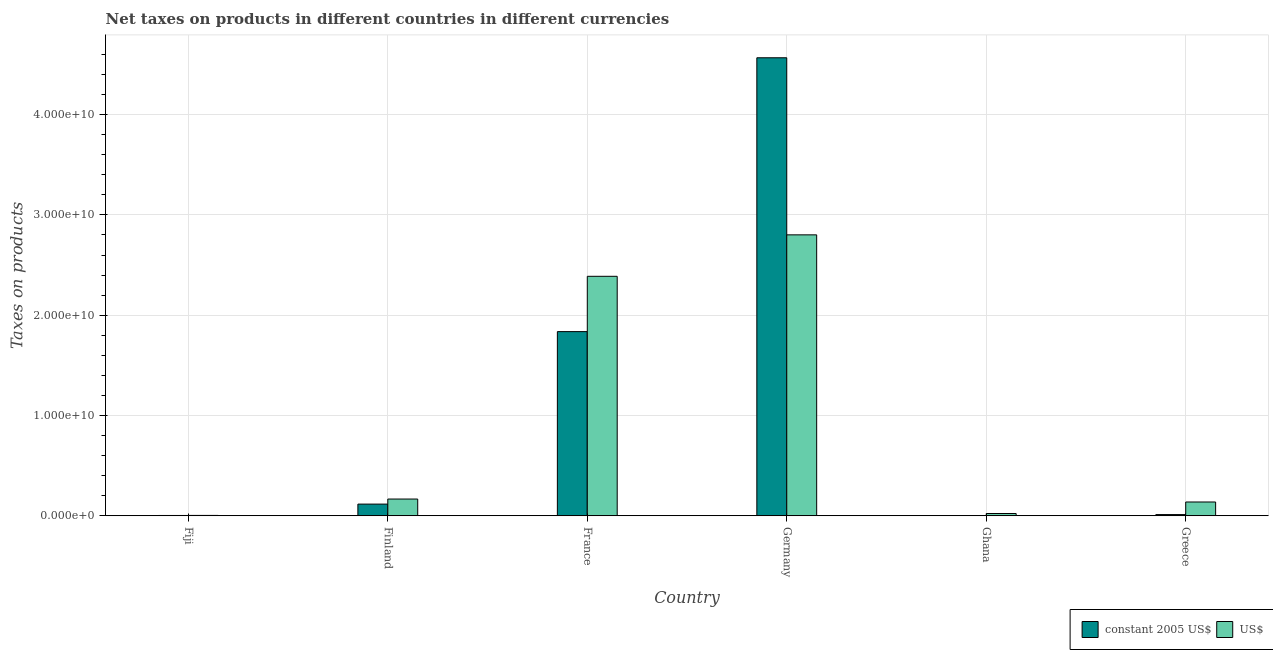Are the number of bars on each tick of the X-axis equal?
Offer a terse response. Yes. How many bars are there on the 4th tick from the right?
Provide a succinct answer. 2. What is the label of the 1st group of bars from the left?
Provide a succinct answer. Fiji. What is the net taxes in constant 2005 us$ in Fiji?
Your response must be concise. 3.08e+07. Across all countries, what is the maximum net taxes in us$?
Ensure brevity in your answer.  2.80e+1. Across all countries, what is the minimum net taxes in constant 2005 us$?
Offer a terse response. 3.03e+04. In which country was the net taxes in constant 2005 us$ maximum?
Provide a short and direct response. Germany. In which country was the net taxes in constant 2005 us$ minimum?
Provide a succinct answer. Ghana. What is the total net taxes in us$ in the graph?
Provide a short and direct response. 5.52e+1. What is the difference between the net taxes in constant 2005 us$ in Ghana and that in Greece?
Make the answer very short. -1.21e+08. What is the difference between the net taxes in us$ in Greece and the net taxes in constant 2005 us$ in Finland?
Your answer should be very brief. 2.11e+08. What is the average net taxes in constant 2005 us$ per country?
Your response must be concise. 1.09e+1. What is the difference between the net taxes in constant 2005 us$ and net taxes in us$ in Fiji?
Keep it short and to the point. -6.52e+06. In how many countries, is the net taxes in constant 2005 us$ greater than 10000000000 units?
Your answer should be very brief. 2. What is the ratio of the net taxes in constant 2005 us$ in France to that in Germany?
Offer a very short reply. 0.4. Is the difference between the net taxes in us$ in Fiji and Ghana greater than the difference between the net taxes in constant 2005 us$ in Fiji and Ghana?
Offer a very short reply. No. What is the difference between the highest and the second highest net taxes in constant 2005 us$?
Your response must be concise. 2.73e+1. What is the difference between the highest and the lowest net taxes in us$?
Provide a short and direct response. 2.80e+1. In how many countries, is the net taxes in constant 2005 us$ greater than the average net taxes in constant 2005 us$ taken over all countries?
Provide a succinct answer. 2. What does the 2nd bar from the left in France represents?
Your response must be concise. US$. What does the 2nd bar from the right in Fiji represents?
Give a very brief answer. Constant 2005 us$. How many bars are there?
Ensure brevity in your answer.  12. Are all the bars in the graph horizontal?
Your answer should be very brief. No. How many countries are there in the graph?
Your answer should be compact. 6. Are the values on the major ticks of Y-axis written in scientific E-notation?
Provide a succinct answer. Yes. Does the graph contain any zero values?
Keep it short and to the point. No. Does the graph contain grids?
Your answer should be compact. Yes. Where does the legend appear in the graph?
Make the answer very short. Bottom right. What is the title of the graph?
Ensure brevity in your answer.  Net taxes on products in different countries in different currencies. Does "Agricultural land" appear as one of the legend labels in the graph?
Give a very brief answer. No. What is the label or title of the X-axis?
Ensure brevity in your answer.  Country. What is the label or title of the Y-axis?
Your answer should be compact. Taxes on products. What is the Taxes on products of constant 2005 US$ in Fiji?
Keep it short and to the point. 3.08e+07. What is the Taxes on products of US$ in Fiji?
Keep it short and to the point. 3.73e+07. What is the Taxes on products in constant 2005 US$ in Finland?
Keep it short and to the point. 1.17e+09. What is the Taxes on products in US$ in Finland?
Make the answer very short. 1.67e+09. What is the Taxes on products of constant 2005 US$ in France?
Your answer should be compact. 1.84e+1. What is the Taxes on products of US$ in France?
Provide a succinct answer. 2.39e+1. What is the Taxes on products of constant 2005 US$ in Germany?
Make the answer very short. 4.57e+1. What is the Taxes on products in US$ in Germany?
Your response must be concise. 2.80e+1. What is the Taxes on products of constant 2005 US$ in Ghana?
Ensure brevity in your answer.  3.03e+04. What is the Taxes on products of US$ in Ghana?
Provide a succinct answer. 2.27e+08. What is the Taxes on products of constant 2005 US$ in Greece?
Your answer should be compact. 1.21e+08. What is the Taxes on products in US$ in Greece?
Offer a terse response. 1.38e+09. Across all countries, what is the maximum Taxes on products of constant 2005 US$?
Your answer should be very brief. 4.57e+1. Across all countries, what is the maximum Taxes on products of US$?
Your answer should be compact. 2.80e+1. Across all countries, what is the minimum Taxes on products in constant 2005 US$?
Your answer should be compact. 3.03e+04. Across all countries, what is the minimum Taxes on products of US$?
Ensure brevity in your answer.  3.73e+07. What is the total Taxes on products in constant 2005 US$ in the graph?
Your answer should be compact. 6.53e+1. What is the total Taxes on products in US$ in the graph?
Offer a terse response. 5.52e+1. What is the difference between the Taxes on products in constant 2005 US$ in Fiji and that in Finland?
Make the answer very short. -1.13e+09. What is the difference between the Taxes on products in US$ in Fiji and that in Finland?
Your answer should be very brief. -1.63e+09. What is the difference between the Taxes on products in constant 2005 US$ in Fiji and that in France?
Offer a terse response. -1.83e+1. What is the difference between the Taxes on products in US$ in Fiji and that in France?
Make the answer very short. -2.38e+1. What is the difference between the Taxes on products of constant 2005 US$ in Fiji and that in Germany?
Give a very brief answer. -4.56e+1. What is the difference between the Taxes on products of US$ in Fiji and that in Germany?
Keep it short and to the point. -2.80e+1. What is the difference between the Taxes on products of constant 2005 US$ in Fiji and that in Ghana?
Your response must be concise. 3.08e+07. What is the difference between the Taxes on products of US$ in Fiji and that in Ghana?
Your answer should be compact. -1.90e+08. What is the difference between the Taxes on products of constant 2005 US$ in Fiji and that in Greece?
Keep it short and to the point. -9.03e+07. What is the difference between the Taxes on products of US$ in Fiji and that in Greece?
Provide a short and direct response. -1.34e+09. What is the difference between the Taxes on products in constant 2005 US$ in Finland and that in France?
Keep it short and to the point. -1.72e+1. What is the difference between the Taxes on products in US$ in Finland and that in France?
Ensure brevity in your answer.  -2.22e+1. What is the difference between the Taxes on products in constant 2005 US$ in Finland and that in Germany?
Ensure brevity in your answer.  -4.45e+1. What is the difference between the Taxes on products in US$ in Finland and that in Germany?
Offer a very short reply. -2.63e+1. What is the difference between the Taxes on products in constant 2005 US$ in Finland and that in Ghana?
Your response must be concise. 1.17e+09. What is the difference between the Taxes on products of US$ in Finland and that in Ghana?
Offer a very short reply. 1.44e+09. What is the difference between the Taxes on products of constant 2005 US$ in Finland and that in Greece?
Ensure brevity in your answer.  1.04e+09. What is the difference between the Taxes on products of US$ in Finland and that in Greece?
Provide a succinct answer. 2.95e+08. What is the difference between the Taxes on products in constant 2005 US$ in France and that in Germany?
Give a very brief answer. -2.73e+1. What is the difference between the Taxes on products in US$ in France and that in Germany?
Make the answer very short. -4.13e+09. What is the difference between the Taxes on products in constant 2005 US$ in France and that in Ghana?
Provide a short and direct response. 1.84e+1. What is the difference between the Taxes on products in US$ in France and that in Ghana?
Offer a very short reply. 2.36e+1. What is the difference between the Taxes on products in constant 2005 US$ in France and that in Greece?
Ensure brevity in your answer.  1.82e+1. What is the difference between the Taxes on products of US$ in France and that in Greece?
Make the answer very short. 2.25e+1. What is the difference between the Taxes on products in constant 2005 US$ in Germany and that in Ghana?
Provide a succinct answer. 4.57e+1. What is the difference between the Taxes on products of US$ in Germany and that in Ghana?
Make the answer very short. 2.78e+1. What is the difference between the Taxes on products in constant 2005 US$ in Germany and that in Greece?
Ensure brevity in your answer.  4.55e+1. What is the difference between the Taxes on products in US$ in Germany and that in Greece?
Provide a succinct answer. 2.66e+1. What is the difference between the Taxes on products in constant 2005 US$ in Ghana and that in Greece?
Provide a short and direct response. -1.21e+08. What is the difference between the Taxes on products in US$ in Ghana and that in Greece?
Your response must be concise. -1.15e+09. What is the difference between the Taxes on products of constant 2005 US$ in Fiji and the Taxes on products of US$ in Finland?
Your answer should be very brief. -1.64e+09. What is the difference between the Taxes on products in constant 2005 US$ in Fiji and the Taxes on products in US$ in France?
Provide a succinct answer. -2.38e+1. What is the difference between the Taxes on products of constant 2005 US$ in Fiji and the Taxes on products of US$ in Germany?
Provide a short and direct response. -2.80e+1. What is the difference between the Taxes on products in constant 2005 US$ in Fiji and the Taxes on products in US$ in Ghana?
Make the answer very short. -1.97e+08. What is the difference between the Taxes on products in constant 2005 US$ in Fiji and the Taxes on products in US$ in Greece?
Give a very brief answer. -1.35e+09. What is the difference between the Taxes on products of constant 2005 US$ in Finland and the Taxes on products of US$ in France?
Ensure brevity in your answer.  -2.27e+1. What is the difference between the Taxes on products of constant 2005 US$ in Finland and the Taxes on products of US$ in Germany?
Your answer should be very brief. -2.68e+1. What is the difference between the Taxes on products in constant 2005 US$ in Finland and the Taxes on products in US$ in Ghana?
Ensure brevity in your answer.  9.38e+08. What is the difference between the Taxes on products in constant 2005 US$ in Finland and the Taxes on products in US$ in Greece?
Give a very brief answer. -2.11e+08. What is the difference between the Taxes on products in constant 2005 US$ in France and the Taxes on products in US$ in Germany?
Offer a terse response. -9.65e+09. What is the difference between the Taxes on products in constant 2005 US$ in France and the Taxes on products in US$ in Ghana?
Ensure brevity in your answer.  1.81e+1. What is the difference between the Taxes on products of constant 2005 US$ in France and the Taxes on products of US$ in Greece?
Offer a terse response. 1.70e+1. What is the difference between the Taxes on products of constant 2005 US$ in Germany and the Taxes on products of US$ in Ghana?
Provide a succinct answer. 4.54e+1. What is the difference between the Taxes on products in constant 2005 US$ in Germany and the Taxes on products in US$ in Greece?
Make the answer very short. 4.43e+1. What is the difference between the Taxes on products of constant 2005 US$ in Ghana and the Taxes on products of US$ in Greece?
Your response must be concise. -1.38e+09. What is the average Taxes on products of constant 2005 US$ per country?
Offer a terse response. 1.09e+1. What is the average Taxes on products in US$ per country?
Offer a very short reply. 9.20e+09. What is the difference between the Taxes on products of constant 2005 US$ and Taxes on products of US$ in Fiji?
Give a very brief answer. -6.52e+06. What is the difference between the Taxes on products in constant 2005 US$ and Taxes on products in US$ in Finland?
Your answer should be compact. -5.06e+08. What is the difference between the Taxes on products in constant 2005 US$ and Taxes on products in US$ in France?
Keep it short and to the point. -5.52e+09. What is the difference between the Taxes on products in constant 2005 US$ and Taxes on products in US$ in Germany?
Offer a very short reply. 1.77e+1. What is the difference between the Taxes on products in constant 2005 US$ and Taxes on products in US$ in Ghana?
Make the answer very short. -2.27e+08. What is the difference between the Taxes on products of constant 2005 US$ and Taxes on products of US$ in Greece?
Keep it short and to the point. -1.25e+09. What is the ratio of the Taxes on products in constant 2005 US$ in Fiji to that in Finland?
Provide a succinct answer. 0.03. What is the ratio of the Taxes on products of US$ in Fiji to that in Finland?
Provide a short and direct response. 0.02. What is the ratio of the Taxes on products of constant 2005 US$ in Fiji to that in France?
Ensure brevity in your answer.  0. What is the ratio of the Taxes on products of US$ in Fiji to that in France?
Your response must be concise. 0. What is the ratio of the Taxes on products of constant 2005 US$ in Fiji to that in Germany?
Provide a short and direct response. 0. What is the ratio of the Taxes on products of US$ in Fiji to that in Germany?
Make the answer very short. 0. What is the ratio of the Taxes on products of constant 2005 US$ in Fiji to that in Ghana?
Provide a short and direct response. 1016.5. What is the ratio of the Taxes on products in US$ in Fiji to that in Ghana?
Your response must be concise. 0.16. What is the ratio of the Taxes on products in constant 2005 US$ in Fiji to that in Greece?
Offer a very short reply. 0.25. What is the ratio of the Taxes on products in US$ in Fiji to that in Greece?
Provide a short and direct response. 0.03. What is the ratio of the Taxes on products in constant 2005 US$ in Finland to that in France?
Provide a succinct answer. 0.06. What is the ratio of the Taxes on products of US$ in Finland to that in France?
Keep it short and to the point. 0.07. What is the ratio of the Taxes on products in constant 2005 US$ in Finland to that in Germany?
Ensure brevity in your answer.  0.03. What is the ratio of the Taxes on products of US$ in Finland to that in Germany?
Provide a succinct answer. 0.06. What is the ratio of the Taxes on products of constant 2005 US$ in Finland to that in Ghana?
Ensure brevity in your answer.  3.85e+04. What is the ratio of the Taxes on products in US$ in Finland to that in Ghana?
Your answer should be very brief. 7.35. What is the ratio of the Taxes on products of constant 2005 US$ in Finland to that in Greece?
Make the answer very short. 9.62. What is the ratio of the Taxes on products in US$ in Finland to that in Greece?
Provide a succinct answer. 1.21. What is the ratio of the Taxes on products in constant 2005 US$ in France to that in Germany?
Provide a short and direct response. 0.4. What is the ratio of the Taxes on products in US$ in France to that in Germany?
Ensure brevity in your answer.  0.85. What is the ratio of the Taxes on products of constant 2005 US$ in France to that in Ghana?
Ensure brevity in your answer.  6.06e+05. What is the ratio of the Taxes on products in US$ in France to that in Ghana?
Keep it short and to the point. 105.02. What is the ratio of the Taxes on products of constant 2005 US$ in France to that in Greece?
Provide a succinct answer. 151.63. What is the ratio of the Taxes on products of US$ in France to that in Greece?
Offer a very short reply. 17.35. What is the ratio of the Taxes on products in constant 2005 US$ in Germany to that in Ghana?
Your answer should be compact. 1.51e+06. What is the ratio of the Taxes on products in US$ in Germany to that in Ghana?
Offer a very short reply. 123.19. What is the ratio of the Taxes on products in constant 2005 US$ in Germany to that in Greece?
Give a very brief answer. 377.08. What is the ratio of the Taxes on products in US$ in Germany to that in Greece?
Offer a terse response. 20.35. What is the ratio of the Taxes on products in constant 2005 US$ in Ghana to that in Greece?
Ensure brevity in your answer.  0. What is the ratio of the Taxes on products of US$ in Ghana to that in Greece?
Provide a succinct answer. 0.17. What is the difference between the highest and the second highest Taxes on products in constant 2005 US$?
Give a very brief answer. 2.73e+1. What is the difference between the highest and the second highest Taxes on products in US$?
Your answer should be very brief. 4.13e+09. What is the difference between the highest and the lowest Taxes on products of constant 2005 US$?
Offer a very short reply. 4.57e+1. What is the difference between the highest and the lowest Taxes on products of US$?
Make the answer very short. 2.80e+1. 